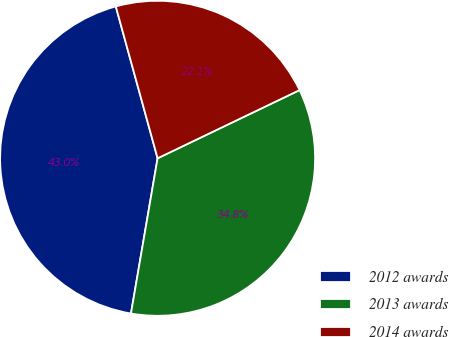<chart> <loc_0><loc_0><loc_500><loc_500><pie_chart><fcel>2012 awards<fcel>2013 awards<fcel>2014 awards<nl><fcel>43.02%<fcel>34.83%<fcel>22.15%<nl></chart> 